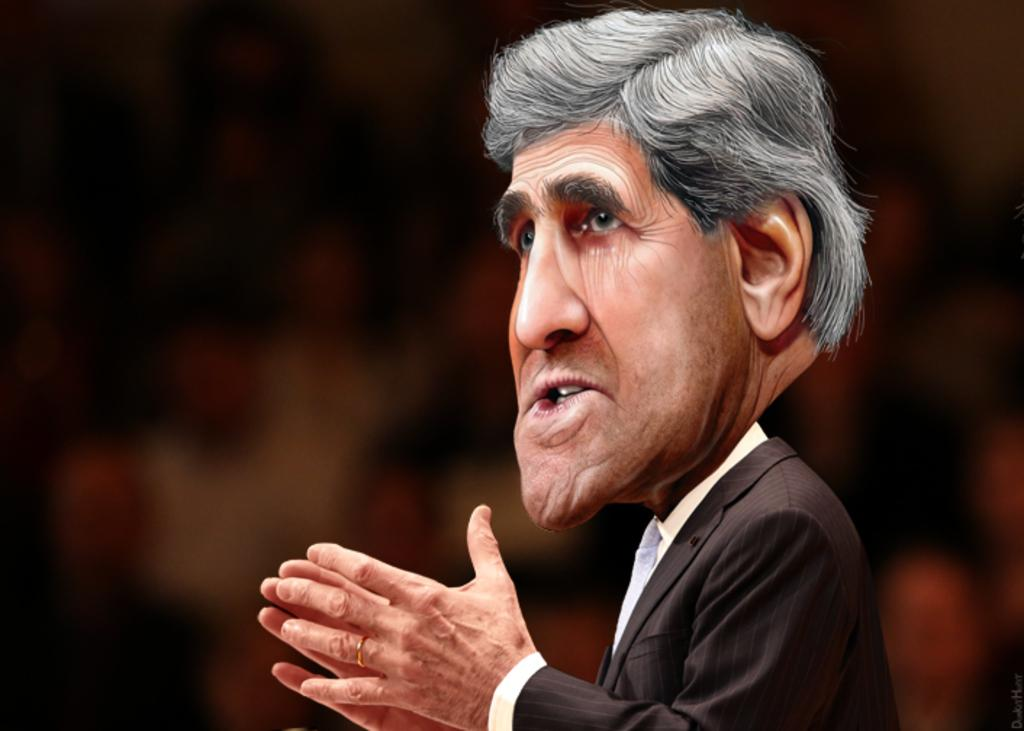What can be said about the nature of the image? The image is edited. Who is present in the image? There is a man in the image. How would you describe the background of the image? The background of the image is dark. What type of quiver can be seen in the image? There is no quiver present in the image. Is there a group of people exchanging items in the image? There is no group of people or exchange of items depicted in the image. 